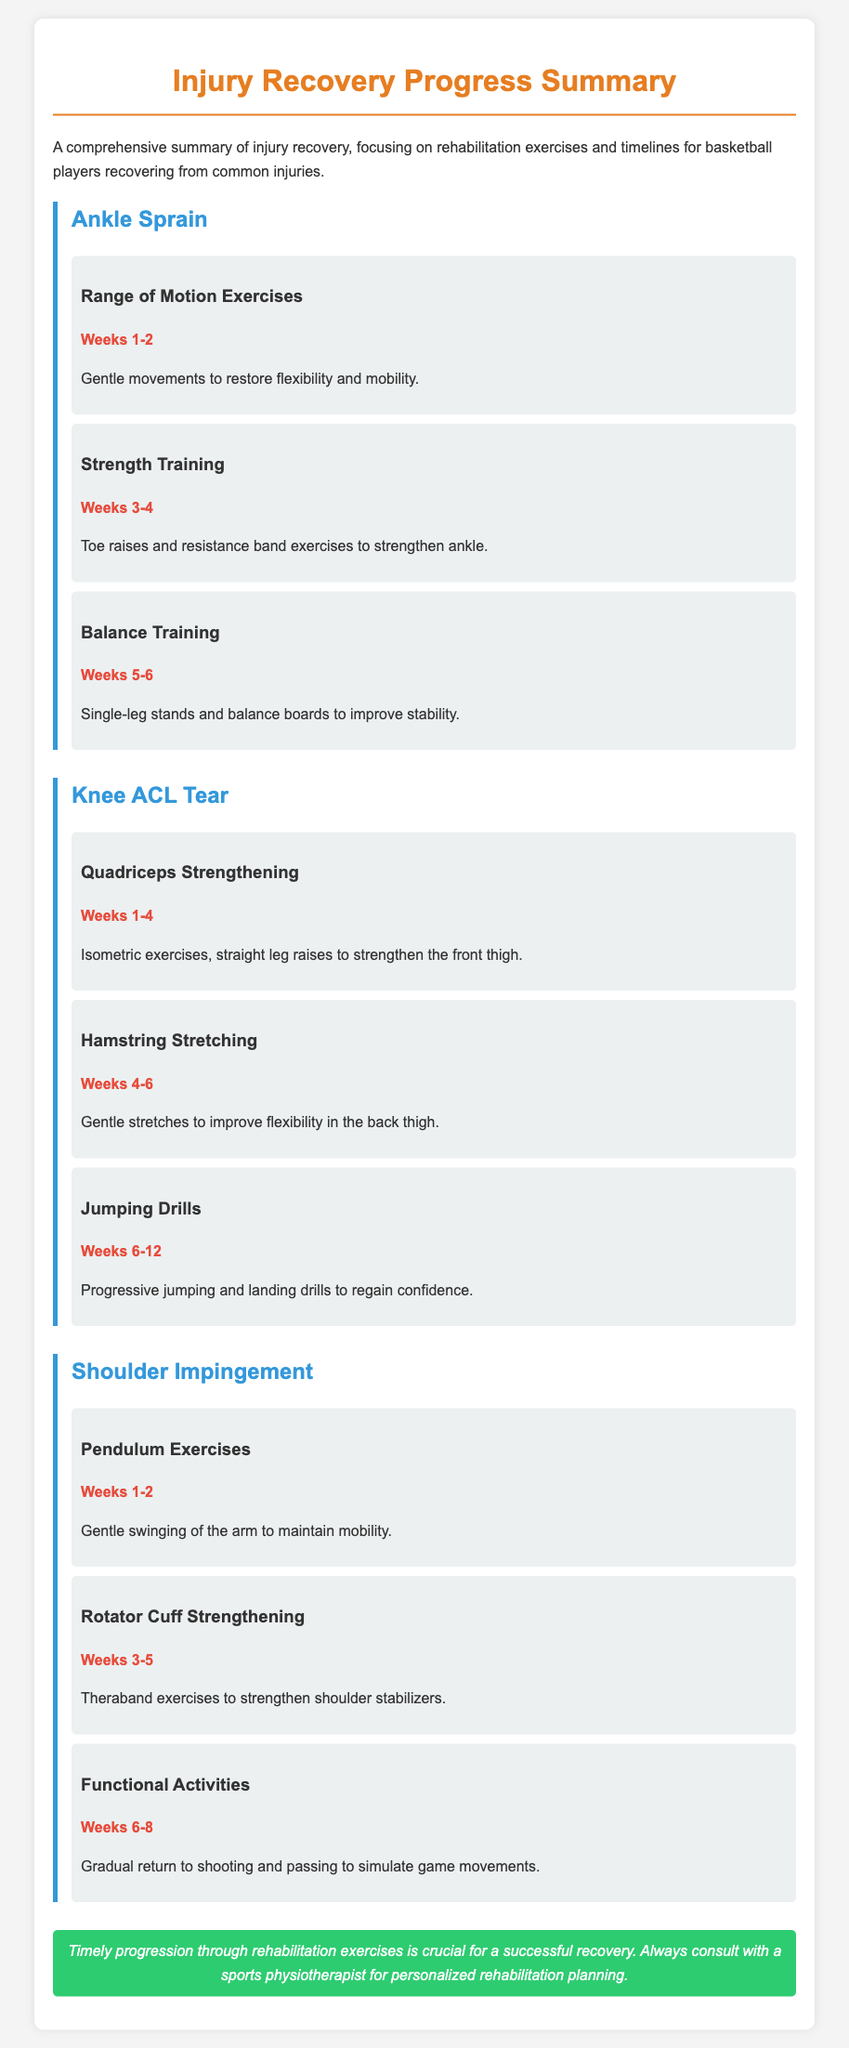what is the focus of the document? The document provides a summary of injury recovery, focusing specifically on rehabilitation exercises and timelines for basketball players.
Answer: injury recovery, rehabilitation exercises, timelines what exercise is recommended during weeks 1-2 for Ankle Sprain? The document lists Range of Motion Exercises during the first two weeks for Ankle Sprain recovery.
Answer: Range of Motion Exercises how many weeks are allocated for balance training after an Ankle Sprain? The document states that balance training is scheduled for weeks 5-6.
Answer: 2 weeks what is the main timeline for Jumping Drills in a Knee ACL Tear recovery? The document specifies that Jumping Drills occur from weeks 6-12 after a Knee ACL Tear.
Answer: weeks 6-12 which exercise follows Pendulum Exercises for Shoulder Impingement? The next exercise after Pendulum Exercises is Rotator Cuff Strengthening.
Answer: Rotator Cuff Strengthening what is the purpose of the conclusion in the document? The conclusion emphasizes the importance of timely progression through rehabilitation exercises and recommends consulting a sports physiotherapist.
Answer: Timely progression is crucial for recovery 